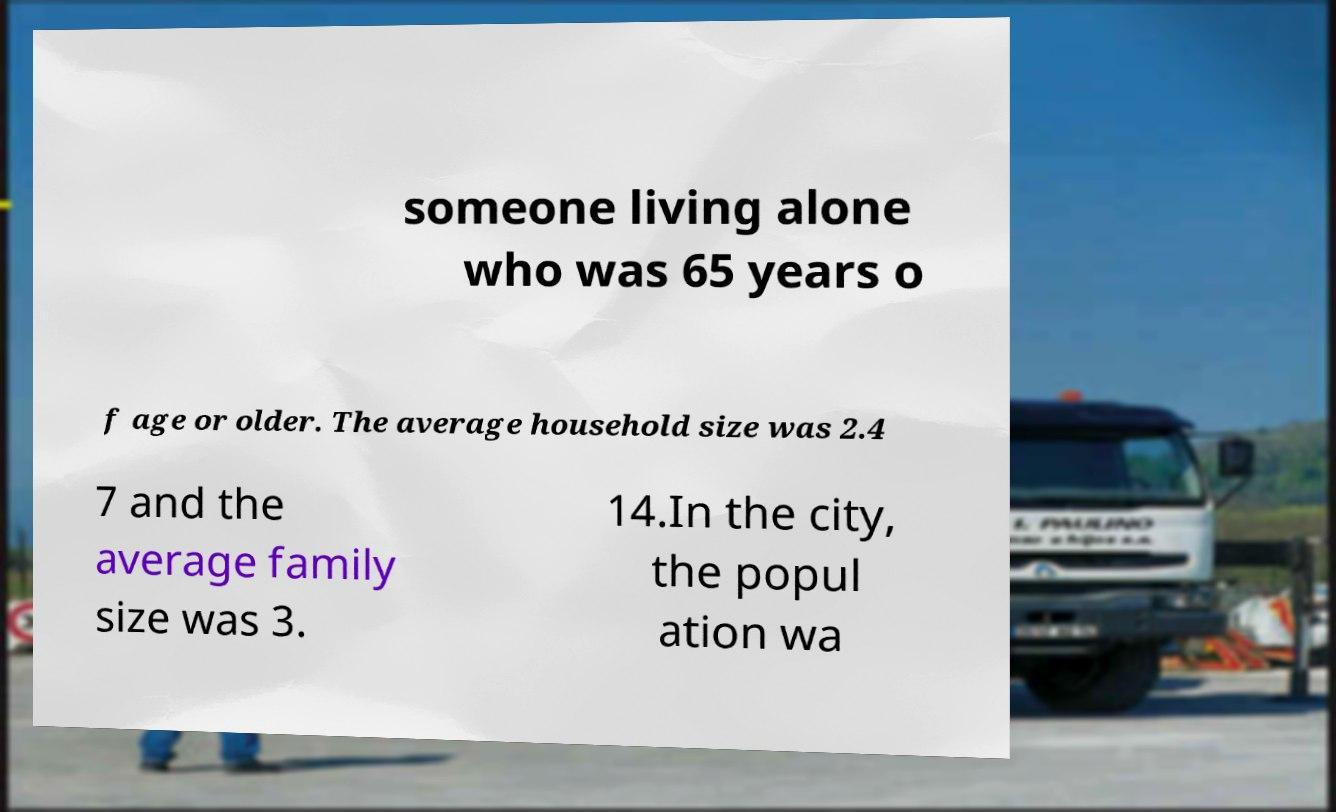What messages or text are displayed in this image? I need them in a readable, typed format. someone living alone who was 65 years o f age or older. The average household size was 2.4 7 and the average family size was 3. 14.In the city, the popul ation wa 